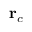<formula> <loc_0><loc_0><loc_500><loc_500>r _ { c }</formula> 